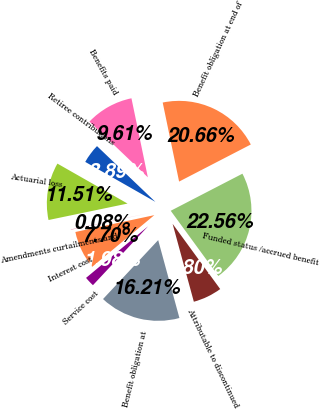Convert chart. <chart><loc_0><loc_0><loc_500><loc_500><pie_chart><fcel>Benefit obligation at<fcel>Service cost<fcel>Interest cost<fcel>Amendments curtailments and<fcel>Actuarial loss<fcel>Retiree contributions<fcel>Benefits paid<fcel>Benefit obligation at end of<fcel>Funded status /accrued benefit<fcel>Attributable to discontinued<nl><fcel>16.21%<fcel>1.98%<fcel>7.7%<fcel>0.08%<fcel>11.51%<fcel>3.89%<fcel>9.61%<fcel>20.66%<fcel>22.56%<fcel>5.8%<nl></chart> 